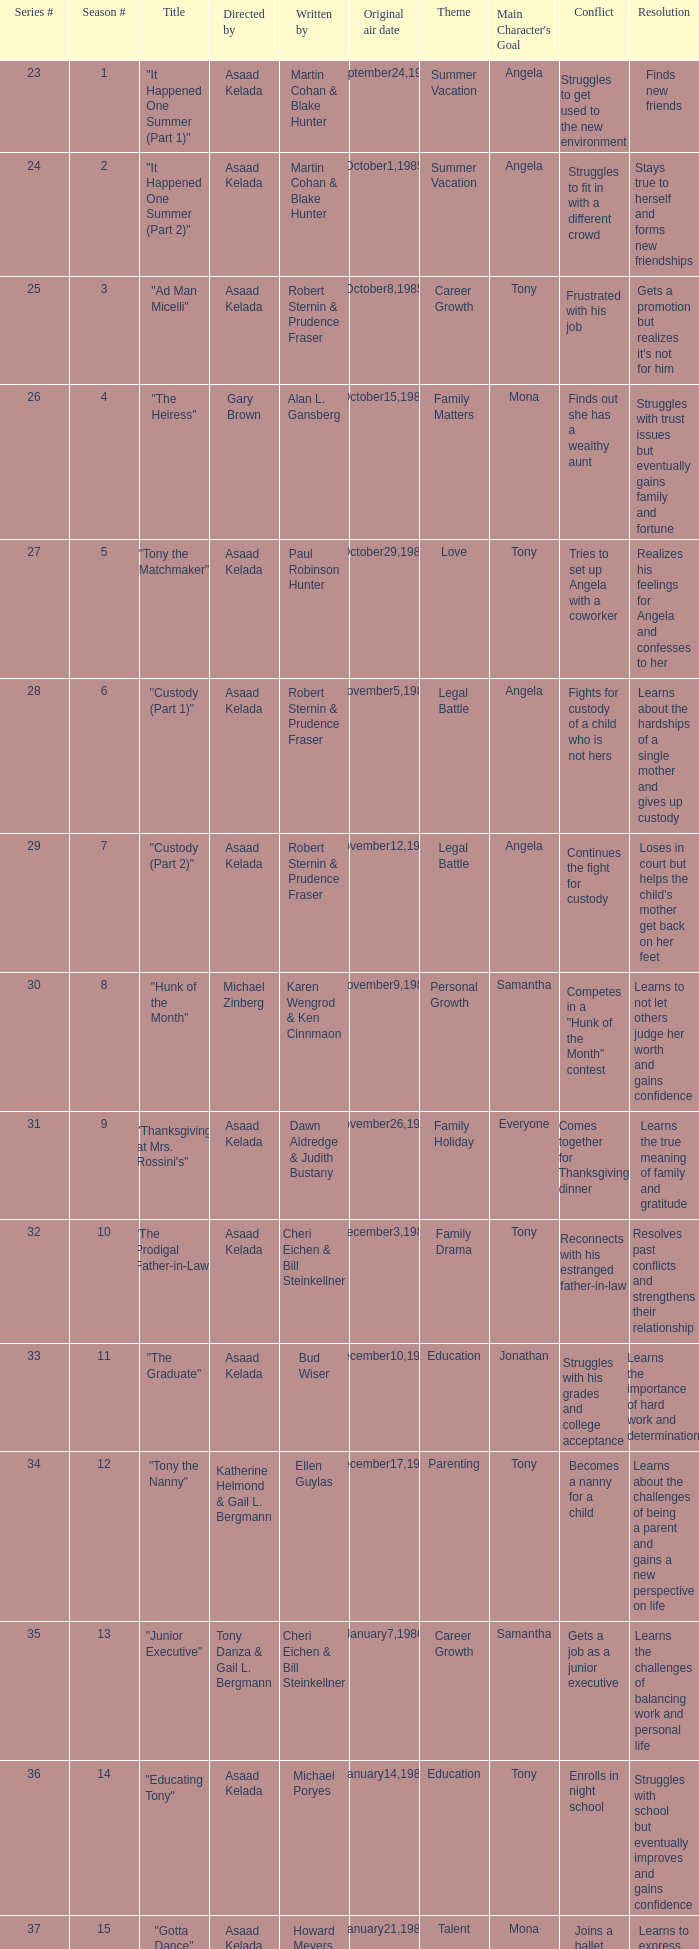Who were the authors of series episode #25? Robert Sternin & Prudence Fraser. 